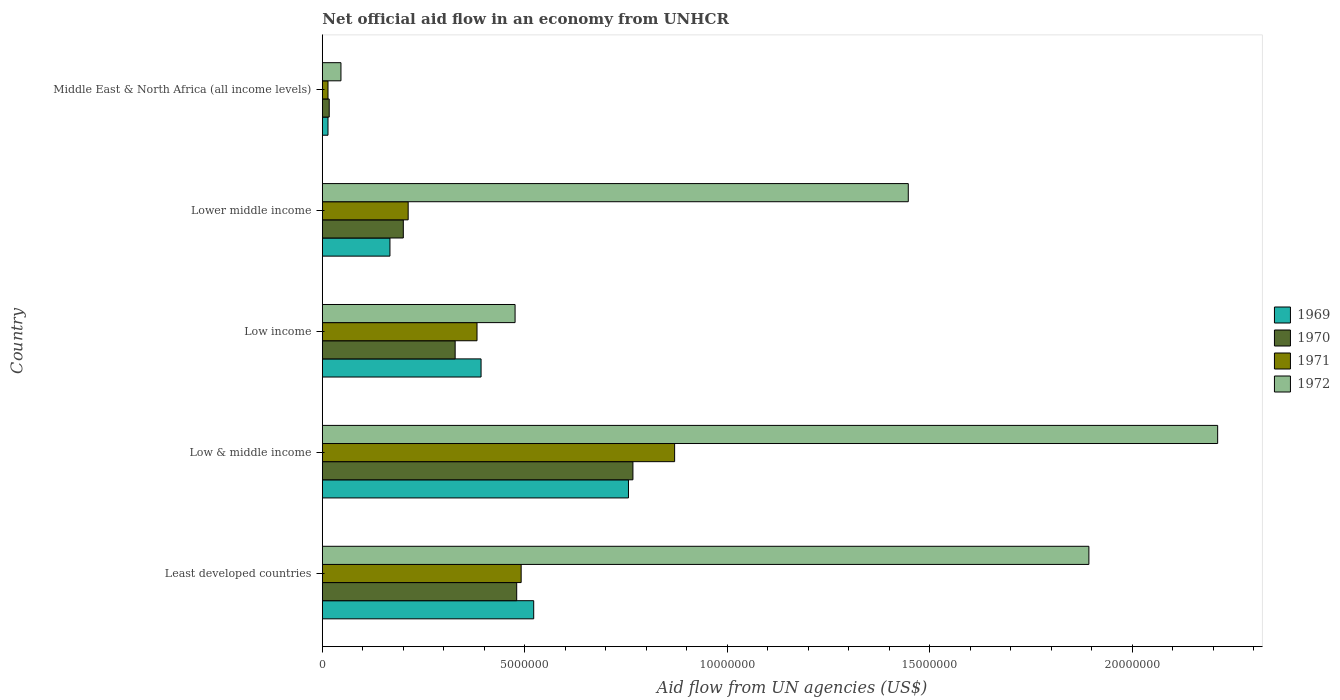How many different coloured bars are there?
Your answer should be compact. 4. How many groups of bars are there?
Offer a very short reply. 5. Are the number of bars per tick equal to the number of legend labels?
Offer a terse response. Yes. How many bars are there on the 2nd tick from the top?
Provide a short and direct response. 4. What is the label of the 1st group of bars from the top?
Provide a succinct answer. Middle East & North Africa (all income levels). In how many cases, is the number of bars for a given country not equal to the number of legend labels?
Your answer should be compact. 0. What is the net official aid flow in 1970 in Lower middle income?
Your answer should be compact. 2.00e+06. Across all countries, what is the maximum net official aid flow in 1969?
Offer a very short reply. 7.56e+06. In which country was the net official aid flow in 1971 minimum?
Offer a terse response. Middle East & North Africa (all income levels). What is the total net official aid flow in 1972 in the graph?
Your answer should be very brief. 6.07e+07. What is the difference between the net official aid flow in 1971 in Lower middle income and that in Middle East & North Africa (all income levels)?
Offer a terse response. 1.98e+06. What is the difference between the net official aid flow in 1972 in Middle East & North Africa (all income levels) and the net official aid flow in 1969 in Low & middle income?
Offer a very short reply. -7.10e+06. What is the average net official aid flow in 1972 per country?
Provide a short and direct response. 1.21e+07. What is the ratio of the net official aid flow in 1972 in Lower middle income to that in Middle East & North Africa (all income levels)?
Keep it short and to the point. 31.46. Is the net official aid flow in 1972 in Low & middle income less than that in Low income?
Provide a short and direct response. No. What is the difference between the highest and the second highest net official aid flow in 1972?
Offer a very short reply. 3.18e+06. What is the difference between the highest and the lowest net official aid flow in 1972?
Give a very brief answer. 2.16e+07. In how many countries, is the net official aid flow in 1969 greater than the average net official aid flow in 1969 taken over all countries?
Provide a short and direct response. 3. Is it the case that in every country, the sum of the net official aid flow in 1972 and net official aid flow in 1970 is greater than the sum of net official aid flow in 1969 and net official aid flow in 1971?
Offer a terse response. No. What does the 3rd bar from the top in Low income represents?
Your answer should be very brief. 1970. Is it the case that in every country, the sum of the net official aid flow in 1972 and net official aid flow in 1969 is greater than the net official aid flow in 1971?
Keep it short and to the point. Yes. How many bars are there?
Provide a short and direct response. 20. What is the difference between two consecutive major ticks on the X-axis?
Ensure brevity in your answer.  5.00e+06. Does the graph contain grids?
Provide a short and direct response. No. Where does the legend appear in the graph?
Provide a succinct answer. Center right. How many legend labels are there?
Provide a short and direct response. 4. What is the title of the graph?
Your answer should be very brief. Net official aid flow in an economy from UNHCR. Does "1986" appear as one of the legend labels in the graph?
Make the answer very short. No. What is the label or title of the X-axis?
Your response must be concise. Aid flow from UN agencies (US$). What is the Aid flow from UN agencies (US$) in 1969 in Least developed countries?
Make the answer very short. 5.22e+06. What is the Aid flow from UN agencies (US$) in 1970 in Least developed countries?
Make the answer very short. 4.80e+06. What is the Aid flow from UN agencies (US$) of 1971 in Least developed countries?
Provide a succinct answer. 4.91e+06. What is the Aid flow from UN agencies (US$) of 1972 in Least developed countries?
Offer a terse response. 1.89e+07. What is the Aid flow from UN agencies (US$) of 1969 in Low & middle income?
Make the answer very short. 7.56e+06. What is the Aid flow from UN agencies (US$) in 1970 in Low & middle income?
Ensure brevity in your answer.  7.67e+06. What is the Aid flow from UN agencies (US$) in 1971 in Low & middle income?
Make the answer very short. 8.70e+06. What is the Aid flow from UN agencies (US$) of 1972 in Low & middle income?
Provide a succinct answer. 2.21e+07. What is the Aid flow from UN agencies (US$) of 1969 in Low income?
Make the answer very short. 3.92e+06. What is the Aid flow from UN agencies (US$) of 1970 in Low income?
Give a very brief answer. 3.28e+06. What is the Aid flow from UN agencies (US$) in 1971 in Low income?
Ensure brevity in your answer.  3.82e+06. What is the Aid flow from UN agencies (US$) in 1972 in Low income?
Your answer should be compact. 4.76e+06. What is the Aid flow from UN agencies (US$) of 1969 in Lower middle income?
Offer a very short reply. 1.67e+06. What is the Aid flow from UN agencies (US$) in 1971 in Lower middle income?
Offer a very short reply. 2.12e+06. What is the Aid flow from UN agencies (US$) of 1972 in Lower middle income?
Your response must be concise. 1.45e+07. Across all countries, what is the maximum Aid flow from UN agencies (US$) in 1969?
Give a very brief answer. 7.56e+06. Across all countries, what is the maximum Aid flow from UN agencies (US$) of 1970?
Your answer should be very brief. 7.67e+06. Across all countries, what is the maximum Aid flow from UN agencies (US$) in 1971?
Offer a very short reply. 8.70e+06. Across all countries, what is the maximum Aid flow from UN agencies (US$) in 1972?
Give a very brief answer. 2.21e+07. Across all countries, what is the minimum Aid flow from UN agencies (US$) in 1970?
Make the answer very short. 1.70e+05. Across all countries, what is the minimum Aid flow from UN agencies (US$) in 1972?
Offer a terse response. 4.60e+05. What is the total Aid flow from UN agencies (US$) of 1969 in the graph?
Give a very brief answer. 1.85e+07. What is the total Aid flow from UN agencies (US$) in 1970 in the graph?
Give a very brief answer. 1.79e+07. What is the total Aid flow from UN agencies (US$) in 1971 in the graph?
Offer a very short reply. 1.97e+07. What is the total Aid flow from UN agencies (US$) in 1972 in the graph?
Offer a very short reply. 6.07e+07. What is the difference between the Aid flow from UN agencies (US$) of 1969 in Least developed countries and that in Low & middle income?
Make the answer very short. -2.34e+06. What is the difference between the Aid flow from UN agencies (US$) in 1970 in Least developed countries and that in Low & middle income?
Ensure brevity in your answer.  -2.87e+06. What is the difference between the Aid flow from UN agencies (US$) in 1971 in Least developed countries and that in Low & middle income?
Your answer should be very brief. -3.79e+06. What is the difference between the Aid flow from UN agencies (US$) of 1972 in Least developed countries and that in Low & middle income?
Offer a terse response. -3.18e+06. What is the difference between the Aid flow from UN agencies (US$) of 1969 in Least developed countries and that in Low income?
Provide a short and direct response. 1.30e+06. What is the difference between the Aid flow from UN agencies (US$) of 1970 in Least developed countries and that in Low income?
Offer a very short reply. 1.52e+06. What is the difference between the Aid flow from UN agencies (US$) of 1971 in Least developed countries and that in Low income?
Provide a succinct answer. 1.09e+06. What is the difference between the Aid flow from UN agencies (US$) in 1972 in Least developed countries and that in Low income?
Offer a very short reply. 1.42e+07. What is the difference between the Aid flow from UN agencies (US$) of 1969 in Least developed countries and that in Lower middle income?
Ensure brevity in your answer.  3.55e+06. What is the difference between the Aid flow from UN agencies (US$) of 1970 in Least developed countries and that in Lower middle income?
Your response must be concise. 2.80e+06. What is the difference between the Aid flow from UN agencies (US$) in 1971 in Least developed countries and that in Lower middle income?
Your answer should be very brief. 2.79e+06. What is the difference between the Aid flow from UN agencies (US$) of 1972 in Least developed countries and that in Lower middle income?
Provide a succinct answer. 4.46e+06. What is the difference between the Aid flow from UN agencies (US$) in 1969 in Least developed countries and that in Middle East & North Africa (all income levels)?
Ensure brevity in your answer.  5.08e+06. What is the difference between the Aid flow from UN agencies (US$) in 1970 in Least developed countries and that in Middle East & North Africa (all income levels)?
Your answer should be very brief. 4.63e+06. What is the difference between the Aid flow from UN agencies (US$) of 1971 in Least developed countries and that in Middle East & North Africa (all income levels)?
Your response must be concise. 4.77e+06. What is the difference between the Aid flow from UN agencies (US$) in 1972 in Least developed countries and that in Middle East & North Africa (all income levels)?
Ensure brevity in your answer.  1.85e+07. What is the difference between the Aid flow from UN agencies (US$) in 1969 in Low & middle income and that in Low income?
Your response must be concise. 3.64e+06. What is the difference between the Aid flow from UN agencies (US$) of 1970 in Low & middle income and that in Low income?
Ensure brevity in your answer.  4.39e+06. What is the difference between the Aid flow from UN agencies (US$) of 1971 in Low & middle income and that in Low income?
Offer a terse response. 4.88e+06. What is the difference between the Aid flow from UN agencies (US$) of 1972 in Low & middle income and that in Low income?
Your answer should be compact. 1.74e+07. What is the difference between the Aid flow from UN agencies (US$) in 1969 in Low & middle income and that in Lower middle income?
Provide a short and direct response. 5.89e+06. What is the difference between the Aid flow from UN agencies (US$) in 1970 in Low & middle income and that in Lower middle income?
Give a very brief answer. 5.67e+06. What is the difference between the Aid flow from UN agencies (US$) in 1971 in Low & middle income and that in Lower middle income?
Offer a very short reply. 6.58e+06. What is the difference between the Aid flow from UN agencies (US$) of 1972 in Low & middle income and that in Lower middle income?
Provide a short and direct response. 7.64e+06. What is the difference between the Aid flow from UN agencies (US$) in 1969 in Low & middle income and that in Middle East & North Africa (all income levels)?
Provide a succinct answer. 7.42e+06. What is the difference between the Aid flow from UN agencies (US$) of 1970 in Low & middle income and that in Middle East & North Africa (all income levels)?
Provide a short and direct response. 7.50e+06. What is the difference between the Aid flow from UN agencies (US$) in 1971 in Low & middle income and that in Middle East & North Africa (all income levels)?
Offer a terse response. 8.56e+06. What is the difference between the Aid flow from UN agencies (US$) in 1972 in Low & middle income and that in Middle East & North Africa (all income levels)?
Offer a terse response. 2.16e+07. What is the difference between the Aid flow from UN agencies (US$) in 1969 in Low income and that in Lower middle income?
Your answer should be very brief. 2.25e+06. What is the difference between the Aid flow from UN agencies (US$) of 1970 in Low income and that in Lower middle income?
Your response must be concise. 1.28e+06. What is the difference between the Aid flow from UN agencies (US$) in 1971 in Low income and that in Lower middle income?
Provide a short and direct response. 1.70e+06. What is the difference between the Aid flow from UN agencies (US$) in 1972 in Low income and that in Lower middle income?
Your answer should be very brief. -9.71e+06. What is the difference between the Aid flow from UN agencies (US$) of 1969 in Low income and that in Middle East & North Africa (all income levels)?
Make the answer very short. 3.78e+06. What is the difference between the Aid flow from UN agencies (US$) in 1970 in Low income and that in Middle East & North Africa (all income levels)?
Keep it short and to the point. 3.11e+06. What is the difference between the Aid flow from UN agencies (US$) of 1971 in Low income and that in Middle East & North Africa (all income levels)?
Provide a short and direct response. 3.68e+06. What is the difference between the Aid flow from UN agencies (US$) of 1972 in Low income and that in Middle East & North Africa (all income levels)?
Your answer should be very brief. 4.30e+06. What is the difference between the Aid flow from UN agencies (US$) in 1969 in Lower middle income and that in Middle East & North Africa (all income levels)?
Keep it short and to the point. 1.53e+06. What is the difference between the Aid flow from UN agencies (US$) in 1970 in Lower middle income and that in Middle East & North Africa (all income levels)?
Provide a succinct answer. 1.83e+06. What is the difference between the Aid flow from UN agencies (US$) of 1971 in Lower middle income and that in Middle East & North Africa (all income levels)?
Offer a very short reply. 1.98e+06. What is the difference between the Aid flow from UN agencies (US$) in 1972 in Lower middle income and that in Middle East & North Africa (all income levels)?
Keep it short and to the point. 1.40e+07. What is the difference between the Aid flow from UN agencies (US$) in 1969 in Least developed countries and the Aid flow from UN agencies (US$) in 1970 in Low & middle income?
Provide a succinct answer. -2.45e+06. What is the difference between the Aid flow from UN agencies (US$) in 1969 in Least developed countries and the Aid flow from UN agencies (US$) in 1971 in Low & middle income?
Provide a succinct answer. -3.48e+06. What is the difference between the Aid flow from UN agencies (US$) in 1969 in Least developed countries and the Aid flow from UN agencies (US$) in 1972 in Low & middle income?
Give a very brief answer. -1.69e+07. What is the difference between the Aid flow from UN agencies (US$) in 1970 in Least developed countries and the Aid flow from UN agencies (US$) in 1971 in Low & middle income?
Ensure brevity in your answer.  -3.90e+06. What is the difference between the Aid flow from UN agencies (US$) in 1970 in Least developed countries and the Aid flow from UN agencies (US$) in 1972 in Low & middle income?
Your answer should be compact. -1.73e+07. What is the difference between the Aid flow from UN agencies (US$) of 1971 in Least developed countries and the Aid flow from UN agencies (US$) of 1972 in Low & middle income?
Offer a terse response. -1.72e+07. What is the difference between the Aid flow from UN agencies (US$) of 1969 in Least developed countries and the Aid flow from UN agencies (US$) of 1970 in Low income?
Your answer should be very brief. 1.94e+06. What is the difference between the Aid flow from UN agencies (US$) in 1969 in Least developed countries and the Aid flow from UN agencies (US$) in 1971 in Low income?
Provide a short and direct response. 1.40e+06. What is the difference between the Aid flow from UN agencies (US$) in 1970 in Least developed countries and the Aid flow from UN agencies (US$) in 1971 in Low income?
Your response must be concise. 9.80e+05. What is the difference between the Aid flow from UN agencies (US$) in 1970 in Least developed countries and the Aid flow from UN agencies (US$) in 1972 in Low income?
Offer a terse response. 4.00e+04. What is the difference between the Aid flow from UN agencies (US$) in 1971 in Least developed countries and the Aid flow from UN agencies (US$) in 1972 in Low income?
Provide a short and direct response. 1.50e+05. What is the difference between the Aid flow from UN agencies (US$) in 1969 in Least developed countries and the Aid flow from UN agencies (US$) in 1970 in Lower middle income?
Your answer should be compact. 3.22e+06. What is the difference between the Aid flow from UN agencies (US$) of 1969 in Least developed countries and the Aid flow from UN agencies (US$) of 1971 in Lower middle income?
Provide a succinct answer. 3.10e+06. What is the difference between the Aid flow from UN agencies (US$) in 1969 in Least developed countries and the Aid flow from UN agencies (US$) in 1972 in Lower middle income?
Make the answer very short. -9.25e+06. What is the difference between the Aid flow from UN agencies (US$) of 1970 in Least developed countries and the Aid flow from UN agencies (US$) of 1971 in Lower middle income?
Your answer should be compact. 2.68e+06. What is the difference between the Aid flow from UN agencies (US$) of 1970 in Least developed countries and the Aid flow from UN agencies (US$) of 1972 in Lower middle income?
Your answer should be compact. -9.67e+06. What is the difference between the Aid flow from UN agencies (US$) of 1971 in Least developed countries and the Aid flow from UN agencies (US$) of 1972 in Lower middle income?
Provide a short and direct response. -9.56e+06. What is the difference between the Aid flow from UN agencies (US$) of 1969 in Least developed countries and the Aid flow from UN agencies (US$) of 1970 in Middle East & North Africa (all income levels)?
Keep it short and to the point. 5.05e+06. What is the difference between the Aid flow from UN agencies (US$) in 1969 in Least developed countries and the Aid flow from UN agencies (US$) in 1971 in Middle East & North Africa (all income levels)?
Offer a very short reply. 5.08e+06. What is the difference between the Aid flow from UN agencies (US$) of 1969 in Least developed countries and the Aid flow from UN agencies (US$) of 1972 in Middle East & North Africa (all income levels)?
Your answer should be compact. 4.76e+06. What is the difference between the Aid flow from UN agencies (US$) in 1970 in Least developed countries and the Aid flow from UN agencies (US$) in 1971 in Middle East & North Africa (all income levels)?
Offer a terse response. 4.66e+06. What is the difference between the Aid flow from UN agencies (US$) in 1970 in Least developed countries and the Aid flow from UN agencies (US$) in 1972 in Middle East & North Africa (all income levels)?
Your answer should be very brief. 4.34e+06. What is the difference between the Aid flow from UN agencies (US$) in 1971 in Least developed countries and the Aid flow from UN agencies (US$) in 1972 in Middle East & North Africa (all income levels)?
Your response must be concise. 4.45e+06. What is the difference between the Aid flow from UN agencies (US$) of 1969 in Low & middle income and the Aid flow from UN agencies (US$) of 1970 in Low income?
Provide a short and direct response. 4.28e+06. What is the difference between the Aid flow from UN agencies (US$) of 1969 in Low & middle income and the Aid flow from UN agencies (US$) of 1971 in Low income?
Give a very brief answer. 3.74e+06. What is the difference between the Aid flow from UN agencies (US$) of 1969 in Low & middle income and the Aid flow from UN agencies (US$) of 1972 in Low income?
Your response must be concise. 2.80e+06. What is the difference between the Aid flow from UN agencies (US$) of 1970 in Low & middle income and the Aid flow from UN agencies (US$) of 1971 in Low income?
Your answer should be very brief. 3.85e+06. What is the difference between the Aid flow from UN agencies (US$) in 1970 in Low & middle income and the Aid flow from UN agencies (US$) in 1972 in Low income?
Your answer should be very brief. 2.91e+06. What is the difference between the Aid flow from UN agencies (US$) of 1971 in Low & middle income and the Aid flow from UN agencies (US$) of 1972 in Low income?
Provide a succinct answer. 3.94e+06. What is the difference between the Aid flow from UN agencies (US$) in 1969 in Low & middle income and the Aid flow from UN agencies (US$) in 1970 in Lower middle income?
Your response must be concise. 5.56e+06. What is the difference between the Aid flow from UN agencies (US$) of 1969 in Low & middle income and the Aid flow from UN agencies (US$) of 1971 in Lower middle income?
Your answer should be compact. 5.44e+06. What is the difference between the Aid flow from UN agencies (US$) in 1969 in Low & middle income and the Aid flow from UN agencies (US$) in 1972 in Lower middle income?
Ensure brevity in your answer.  -6.91e+06. What is the difference between the Aid flow from UN agencies (US$) in 1970 in Low & middle income and the Aid flow from UN agencies (US$) in 1971 in Lower middle income?
Make the answer very short. 5.55e+06. What is the difference between the Aid flow from UN agencies (US$) in 1970 in Low & middle income and the Aid flow from UN agencies (US$) in 1972 in Lower middle income?
Offer a very short reply. -6.80e+06. What is the difference between the Aid flow from UN agencies (US$) of 1971 in Low & middle income and the Aid flow from UN agencies (US$) of 1972 in Lower middle income?
Your response must be concise. -5.77e+06. What is the difference between the Aid flow from UN agencies (US$) of 1969 in Low & middle income and the Aid flow from UN agencies (US$) of 1970 in Middle East & North Africa (all income levels)?
Give a very brief answer. 7.39e+06. What is the difference between the Aid flow from UN agencies (US$) in 1969 in Low & middle income and the Aid flow from UN agencies (US$) in 1971 in Middle East & North Africa (all income levels)?
Offer a terse response. 7.42e+06. What is the difference between the Aid flow from UN agencies (US$) of 1969 in Low & middle income and the Aid flow from UN agencies (US$) of 1972 in Middle East & North Africa (all income levels)?
Provide a succinct answer. 7.10e+06. What is the difference between the Aid flow from UN agencies (US$) in 1970 in Low & middle income and the Aid flow from UN agencies (US$) in 1971 in Middle East & North Africa (all income levels)?
Provide a short and direct response. 7.53e+06. What is the difference between the Aid flow from UN agencies (US$) in 1970 in Low & middle income and the Aid flow from UN agencies (US$) in 1972 in Middle East & North Africa (all income levels)?
Keep it short and to the point. 7.21e+06. What is the difference between the Aid flow from UN agencies (US$) in 1971 in Low & middle income and the Aid flow from UN agencies (US$) in 1972 in Middle East & North Africa (all income levels)?
Keep it short and to the point. 8.24e+06. What is the difference between the Aid flow from UN agencies (US$) of 1969 in Low income and the Aid flow from UN agencies (US$) of 1970 in Lower middle income?
Offer a very short reply. 1.92e+06. What is the difference between the Aid flow from UN agencies (US$) in 1969 in Low income and the Aid flow from UN agencies (US$) in 1971 in Lower middle income?
Give a very brief answer. 1.80e+06. What is the difference between the Aid flow from UN agencies (US$) in 1969 in Low income and the Aid flow from UN agencies (US$) in 1972 in Lower middle income?
Provide a succinct answer. -1.06e+07. What is the difference between the Aid flow from UN agencies (US$) in 1970 in Low income and the Aid flow from UN agencies (US$) in 1971 in Lower middle income?
Give a very brief answer. 1.16e+06. What is the difference between the Aid flow from UN agencies (US$) of 1970 in Low income and the Aid flow from UN agencies (US$) of 1972 in Lower middle income?
Keep it short and to the point. -1.12e+07. What is the difference between the Aid flow from UN agencies (US$) in 1971 in Low income and the Aid flow from UN agencies (US$) in 1972 in Lower middle income?
Keep it short and to the point. -1.06e+07. What is the difference between the Aid flow from UN agencies (US$) of 1969 in Low income and the Aid flow from UN agencies (US$) of 1970 in Middle East & North Africa (all income levels)?
Offer a terse response. 3.75e+06. What is the difference between the Aid flow from UN agencies (US$) in 1969 in Low income and the Aid flow from UN agencies (US$) in 1971 in Middle East & North Africa (all income levels)?
Make the answer very short. 3.78e+06. What is the difference between the Aid flow from UN agencies (US$) of 1969 in Low income and the Aid flow from UN agencies (US$) of 1972 in Middle East & North Africa (all income levels)?
Make the answer very short. 3.46e+06. What is the difference between the Aid flow from UN agencies (US$) of 1970 in Low income and the Aid flow from UN agencies (US$) of 1971 in Middle East & North Africa (all income levels)?
Your answer should be very brief. 3.14e+06. What is the difference between the Aid flow from UN agencies (US$) of 1970 in Low income and the Aid flow from UN agencies (US$) of 1972 in Middle East & North Africa (all income levels)?
Give a very brief answer. 2.82e+06. What is the difference between the Aid flow from UN agencies (US$) of 1971 in Low income and the Aid flow from UN agencies (US$) of 1972 in Middle East & North Africa (all income levels)?
Keep it short and to the point. 3.36e+06. What is the difference between the Aid flow from UN agencies (US$) in 1969 in Lower middle income and the Aid flow from UN agencies (US$) in 1970 in Middle East & North Africa (all income levels)?
Provide a short and direct response. 1.50e+06. What is the difference between the Aid flow from UN agencies (US$) of 1969 in Lower middle income and the Aid flow from UN agencies (US$) of 1971 in Middle East & North Africa (all income levels)?
Offer a very short reply. 1.53e+06. What is the difference between the Aid flow from UN agencies (US$) of 1969 in Lower middle income and the Aid flow from UN agencies (US$) of 1972 in Middle East & North Africa (all income levels)?
Give a very brief answer. 1.21e+06. What is the difference between the Aid flow from UN agencies (US$) of 1970 in Lower middle income and the Aid flow from UN agencies (US$) of 1971 in Middle East & North Africa (all income levels)?
Keep it short and to the point. 1.86e+06. What is the difference between the Aid flow from UN agencies (US$) of 1970 in Lower middle income and the Aid flow from UN agencies (US$) of 1972 in Middle East & North Africa (all income levels)?
Offer a very short reply. 1.54e+06. What is the difference between the Aid flow from UN agencies (US$) in 1971 in Lower middle income and the Aid flow from UN agencies (US$) in 1972 in Middle East & North Africa (all income levels)?
Your answer should be compact. 1.66e+06. What is the average Aid flow from UN agencies (US$) in 1969 per country?
Give a very brief answer. 3.70e+06. What is the average Aid flow from UN agencies (US$) of 1970 per country?
Provide a short and direct response. 3.58e+06. What is the average Aid flow from UN agencies (US$) in 1971 per country?
Your answer should be very brief. 3.94e+06. What is the average Aid flow from UN agencies (US$) in 1972 per country?
Your response must be concise. 1.21e+07. What is the difference between the Aid flow from UN agencies (US$) of 1969 and Aid flow from UN agencies (US$) of 1970 in Least developed countries?
Offer a terse response. 4.20e+05. What is the difference between the Aid flow from UN agencies (US$) of 1969 and Aid flow from UN agencies (US$) of 1972 in Least developed countries?
Provide a succinct answer. -1.37e+07. What is the difference between the Aid flow from UN agencies (US$) of 1970 and Aid flow from UN agencies (US$) of 1972 in Least developed countries?
Ensure brevity in your answer.  -1.41e+07. What is the difference between the Aid flow from UN agencies (US$) in 1971 and Aid flow from UN agencies (US$) in 1972 in Least developed countries?
Ensure brevity in your answer.  -1.40e+07. What is the difference between the Aid flow from UN agencies (US$) of 1969 and Aid flow from UN agencies (US$) of 1970 in Low & middle income?
Your answer should be compact. -1.10e+05. What is the difference between the Aid flow from UN agencies (US$) in 1969 and Aid flow from UN agencies (US$) in 1971 in Low & middle income?
Make the answer very short. -1.14e+06. What is the difference between the Aid flow from UN agencies (US$) in 1969 and Aid flow from UN agencies (US$) in 1972 in Low & middle income?
Provide a short and direct response. -1.46e+07. What is the difference between the Aid flow from UN agencies (US$) in 1970 and Aid flow from UN agencies (US$) in 1971 in Low & middle income?
Make the answer very short. -1.03e+06. What is the difference between the Aid flow from UN agencies (US$) in 1970 and Aid flow from UN agencies (US$) in 1972 in Low & middle income?
Provide a succinct answer. -1.44e+07. What is the difference between the Aid flow from UN agencies (US$) in 1971 and Aid flow from UN agencies (US$) in 1972 in Low & middle income?
Ensure brevity in your answer.  -1.34e+07. What is the difference between the Aid flow from UN agencies (US$) in 1969 and Aid flow from UN agencies (US$) in 1970 in Low income?
Ensure brevity in your answer.  6.40e+05. What is the difference between the Aid flow from UN agencies (US$) in 1969 and Aid flow from UN agencies (US$) in 1972 in Low income?
Provide a short and direct response. -8.40e+05. What is the difference between the Aid flow from UN agencies (US$) in 1970 and Aid flow from UN agencies (US$) in 1971 in Low income?
Give a very brief answer. -5.40e+05. What is the difference between the Aid flow from UN agencies (US$) in 1970 and Aid flow from UN agencies (US$) in 1972 in Low income?
Offer a terse response. -1.48e+06. What is the difference between the Aid flow from UN agencies (US$) of 1971 and Aid flow from UN agencies (US$) of 1972 in Low income?
Make the answer very short. -9.40e+05. What is the difference between the Aid flow from UN agencies (US$) in 1969 and Aid flow from UN agencies (US$) in 1970 in Lower middle income?
Make the answer very short. -3.30e+05. What is the difference between the Aid flow from UN agencies (US$) in 1969 and Aid flow from UN agencies (US$) in 1971 in Lower middle income?
Your answer should be very brief. -4.50e+05. What is the difference between the Aid flow from UN agencies (US$) in 1969 and Aid flow from UN agencies (US$) in 1972 in Lower middle income?
Make the answer very short. -1.28e+07. What is the difference between the Aid flow from UN agencies (US$) in 1970 and Aid flow from UN agencies (US$) in 1971 in Lower middle income?
Offer a terse response. -1.20e+05. What is the difference between the Aid flow from UN agencies (US$) of 1970 and Aid flow from UN agencies (US$) of 1972 in Lower middle income?
Your answer should be very brief. -1.25e+07. What is the difference between the Aid flow from UN agencies (US$) of 1971 and Aid flow from UN agencies (US$) of 1972 in Lower middle income?
Provide a short and direct response. -1.24e+07. What is the difference between the Aid flow from UN agencies (US$) in 1969 and Aid flow from UN agencies (US$) in 1970 in Middle East & North Africa (all income levels)?
Provide a succinct answer. -3.00e+04. What is the difference between the Aid flow from UN agencies (US$) in 1969 and Aid flow from UN agencies (US$) in 1972 in Middle East & North Africa (all income levels)?
Offer a very short reply. -3.20e+05. What is the difference between the Aid flow from UN agencies (US$) in 1970 and Aid flow from UN agencies (US$) in 1972 in Middle East & North Africa (all income levels)?
Your response must be concise. -2.90e+05. What is the difference between the Aid flow from UN agencies (US$) of 1971 and Aid flow from UN agencies (US$) of 1972 in Middle East & North Africa (all income levels)?
Offer a very short reply. -3.20e+05. What is the ratio of the Aid flow from UN agencies (US$) of 1969 in Least developed countries to that in Low & middle income?
Provide a short and direct response. 0.69. What is the ratio of the Aid flow from UN agencies (US$) of 1970 in Least developed countries to that in Low & middle income?
Keep it short and to the point. 0.63. What is the ratio of the Aid flow from UN agencies (US$) of 1971 in Least developed countries to that in Low & middle income?
Your answer should be very brief. 0.56. What is the ratio of the Aid flow from UN agencies (US$) in 1972 in Least developed countries to that in Low & middle income?
Your answer should be very brief. 0.86. What is the ratio of the Aid flow from UN agencies (US$) of 1969 in Least developed countries to that in Low income?
Provide a succinct answer. 1.33. What is the ratio of the Aid flow from UN agencies (US$) in 1970 in Least developed countries to that in Low income?
Offer a very short reply. 1.46. What is the ratio of the Aid flow from UN agencies (US$) of 1971 in Least developed countries to that in Low income?
Make the answer very short. 1.29. What is the ratio of the Aid flow from UN agencies (US$) in 1972 in Least developed countries to that in Low income?
Provide a short and direct response. 3.98. What is the ratio of the Aid flow from UN agencies (US$) in 1969 in Least developed countries to that in Lower middle income?
Provide a short and direct response. 3.13. What is the ratio of the Aid flow from UN agencies (US$) in 1971 in Least developed countries to that in Lower middle income?
Your response must be concise. 2.32. What is the ratio of the Aid flow from UN agencies (US$) of 1972 in Least developed countries to that in Lower middle income?
Give a very brief answer. 1.31. What is the ratio of the Aid flow from UN agencies (US$) of 1969 in Least developed countries to that in Middle East & North Africa (all income levels)?
Your answer should be very brief. 37.29. What is the ratio of the Aid flow from UN agencies (US$) of 1970 in Least developed countries to that in Middle East & North Africa (all income levels)?
Offer a very short reply. 28.24. What is the ratio of the Aid flow from UN agencies (US$) in 1971 in Least developed countries to that in Middle East & North Africa (all income levels)?
Your response must be concise. 35.07. What is the ratio of the Aid flow from UN agencies (US$) of 1972 in Least developed countries to that in Middle East & North Africa (all income levels)?
Ensure brevity in your answer.  41.15. What is the ratio of the Aid flow from UN agencies (US$) in 1969 in Low & middle income to that in Low income?
Ensure brevity in your answer.  1.93. What is the ratio of the Aid flow from UN agencies (US$) in 1970 in Low & middle income to that in Low income?
Your answer should be compact. 2.34. What is the ratio of the Aid flow from UN agencies (US$) of 1971 in Low & middle income to that in Low income?
Provide a succinct answer. 2.28. What is the ratio of the Aid flow from UN agencies (US$) in 1972 in Low & middle income to that in Low income?
Make the answer very short. 4.64. What is the ratio of the Aid flow from UN agencies (US$) in 1969 in Low & middle income to that in Lower middle income?
Offer a very short reply. 4.53. What is the ratio of the Aid flow from UN agencies (US$) in 1970 in Low & middle income to that in Lower middle income?
Provide a short and direct response. 3.83. What is the ratio of the Aid flow from UN agencies (US$) in 1971 in Low & middle income to that in Lower middle income?
Make the answer very short. 4.1. What is the ratio of the Aid flow from UN agencies (US$) in 1972 in Low & middle income to that in Lower middle income?
Offer a terse response. 1.53. What is the ratio of the Aid flow from UN agencies (US$) of 1970 in Low & middle income to that in Middle East & North Africa (all income levels)?
Provide a succinct answer. 45.12. What is the ratio of the Aid flow from UN agencies (US$) of 1971 in Low & middle income to that in Middle East & North Africa (all income levels)?
Give a very brief answer. 62.14. What is the ratio of the Aid flow from UN agencies (US$) in 1972 in Low & middle income to that in Middle East & North Africa (all income levels)?
Keep it short and to the point. 48.07. What is the ratio of the Aid flow from UN agencies (US$) in 1969 in Low income to that in Lower middle income?
Provide a succinct answer. 2.35. What is the ratio of the Aid flow from UN agencies (US$) of 1970 in Low income to that in Lower middle income?
Provide a short and direct response. 1.64. What is the ratio of the Aid flow from UN agencies (US$) in 1971 in Low income to that in Lower middle income?
Give a very brief answer. 1.8. What is the ratio of the Aid flow from UN agencies (US$) of 1972 in Low income to that in Lower middle income?
Offer a very short reply. 0.33. What is the ratio of the Aid flow from UN agencies (US$) of 1970 in Low income to that in Middle East & North Africa (all income levels)?
Your response must be concise. 19.29. What is the ratio of the Aid flow from UN agencies (US$) of 1971 in Low income to that in Middle East & North Africa (all income levels)?
Your answer should be compact. 27.29. What is the ratio of the Aid flow from UN agencies (US$) of 1972 in Low income to that in Middle East & North Africa (all income levels)?
Your answer should be compact. 10.35. What is the ratio of the Aid flow from UN agencies (US$) of 1969 in Lower middle income to that in Middle East & North Africa (all income levels)?
Make the answer very short. 11.93. What is the ratio of the Aid flow from UN agencies (US$) in 1970 in Lower middle income to that in Middle East & North Africa (all income levels)?
Your answer should be very brief. 11.76. What is the ratio of the Aid flow from UN agencies (US$) of 1971 in Lower middle income to that in Middle East & North Africa (all income levels)?
Offer a terse response. 15.14. What is the ratio of the Aid flow from UN agencies (US$) in 1972 in Lower middle income to that in Middle East & North Africa (all income levels)?
Give a very brief answer. 31.46. What is the difference between the highest and the second highest Aid flow from UN agencies (US$) in 1969?
Your answer should be compact. 2.34e+06. What is the difference between the highest and the second highest Aid flow from UN agencies (US$) in 1970?
Make the answer very short. 2.87e+06. What is the difference between the highest and the second highest Aid flow from UN agencies (US$) of 1971?
Give a very brief answer. 3.79e+06. What is the difference between the highest and the second highest Aid flow from UN agencies (US$) of 1972?
Offer a very short reply. 3.18e+06. What is the difference between the highest and the lowest Aid flow from UN agencies (US$) of 1969?
Your answer should be very brief. 7.42e+06. What is the difference between the highest and the lowest Aid flow from UN agencies (US$) in 1970?
Make the answer very short. 7.50e+06. What is the difference between the highest and the lowest Aid flow from UN agencies (US$) of 1971?
Your response must be concise. 8.56e+06. What is the difference between the highest and the lowest Aid flow from UN agencies (US$) in 1972?
Make the answer very short. 2.16e+07. 